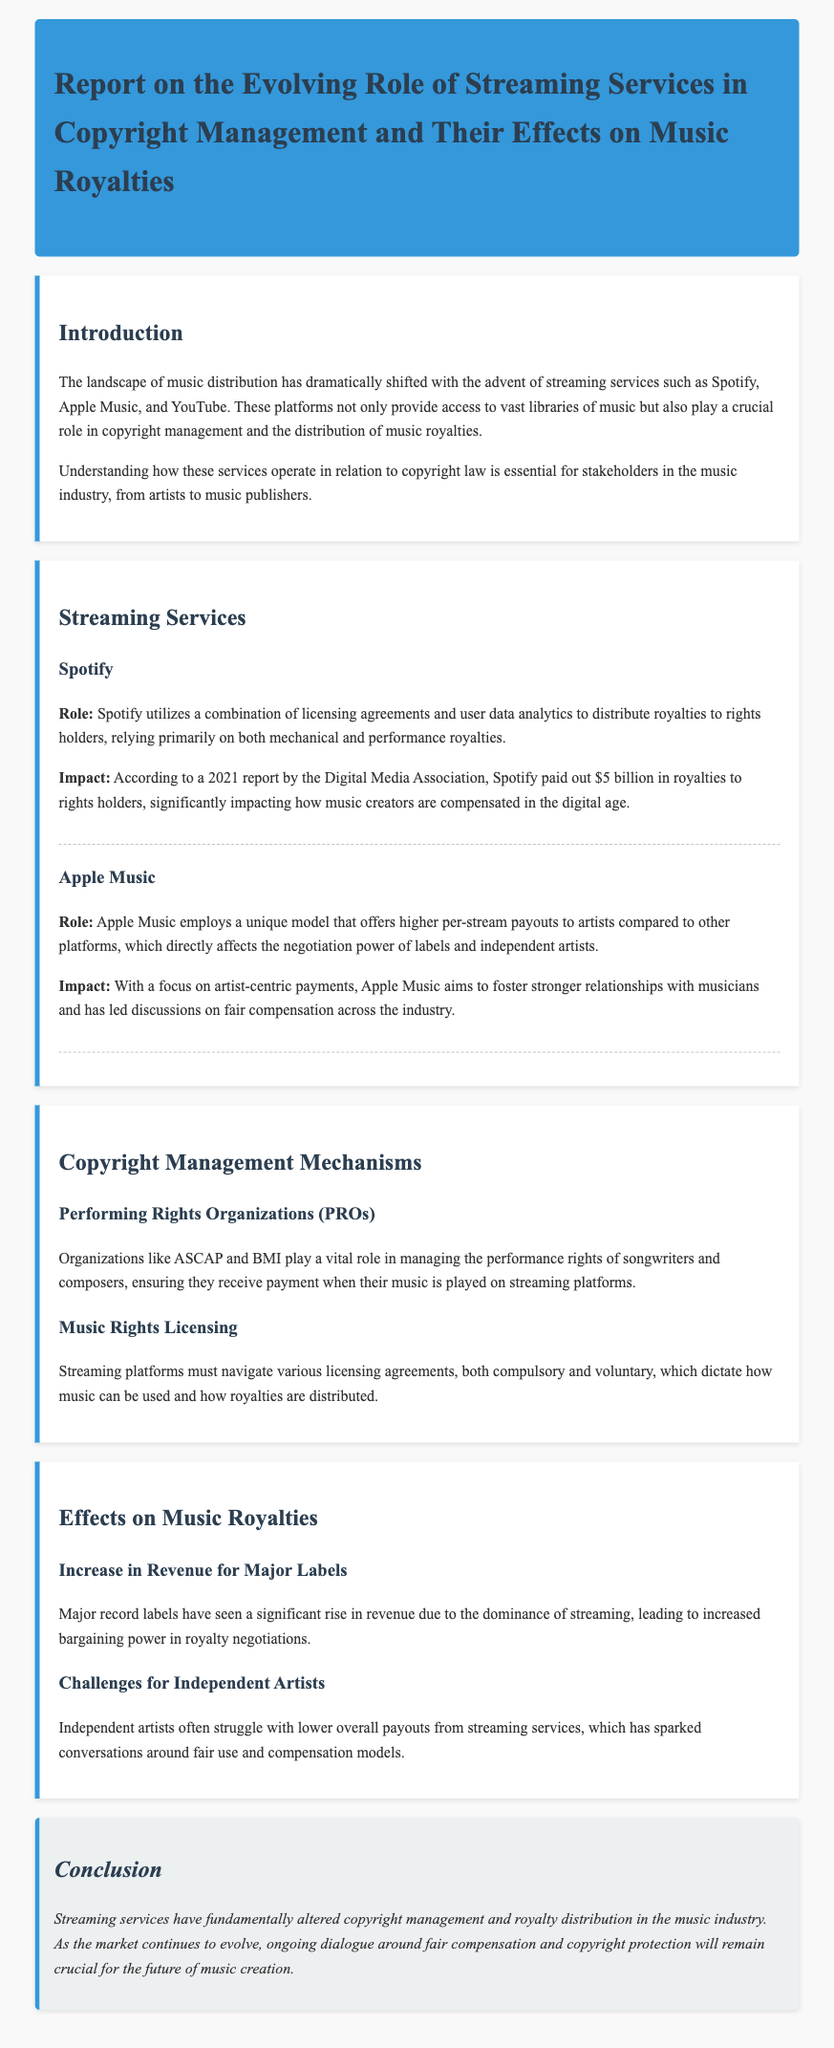what is the title of the report? The title of the report is stated in the header of the document.
Answer: Report on the Evolving Role of Streaming Services in Copyright Management and Their Effects on Music Royalties who are the two streaming services mentioned? The document explicitly lists two streaming services under the "Streaming Services" section.
Answer: Spotify and Apple Music what is the primary royalty type used by Spotify? The document points out the primary royalty types related to Spotify's revenue distribution.
Answer: Mechanical and performance royalties how much did Spotify pay out in royalties according to the 2021 report? The payout figure is given in the context of Spotify's impact on music creation.
Answer: $5 billion what challenge do independent artists face according to the report? The document addresses a specific challenge faced by independent artists in music streaming.
Answer: Lower overall payouts which organizations manage performance rights for songwriters? The report identifies specific organizations responsible for managing performance rights.
Answer: ASCAP and BMI what type of models are sparking conversations around compensation for independent artists? The document discusses models that affect how independent artists are compensated in the streaming context.
Answer: Fair use and compensation models what is the conclusion about the role of streaming services? The conclusion summarizes the impact of streaming services on copyright and royalties.
Answer: Altered copyright management and royalty distribution 